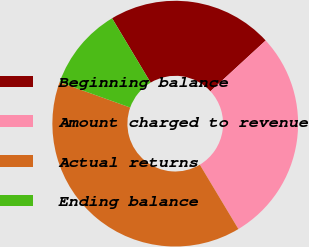<chart> <loc_0><loc_0><loc_500><loc_500><pie_chart><fcel>Beginning balance<fcel>Amount charged to revenue<fcel>Actual returns<fcel>Ending balance<nl><fcel>21.76%<fcel>28.24%<fcel>39.07%<fcel>10.93%<nl></chart> 